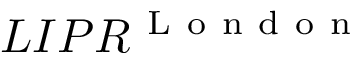<formula> <loc_0><loc_0><loc_500><loc_500>L I P R ^ { L o n d o n }</formula> 